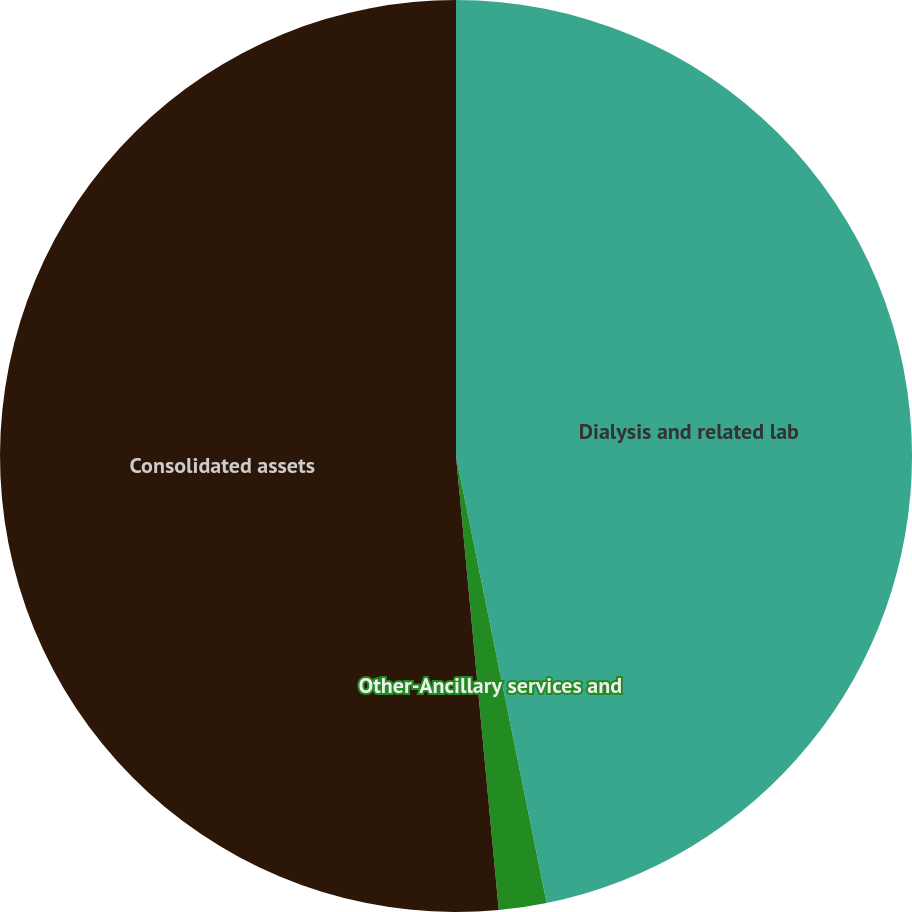<chart> <loc_0><loc_0><loc_500><loc_500><pie_chart><fcel>Dialysis and related lab<fcel>Other-Ancillary services and<fcel>Consolidated assets<nl><fcel>46.81%<fcel>1.69%<fcel>51.49%<nl></chart> 